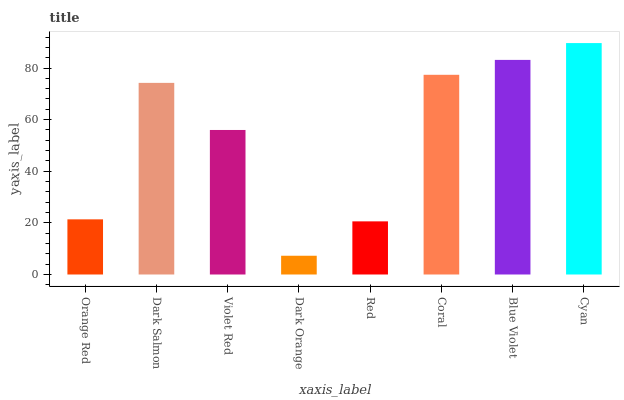Is Dark Orange the minimum?
Answer yes or no. Yes. Is Cyan the maximum?
Answer yes or no. Yes. Is Dark Salmon the minimum?
Answer yes or no. No. Is Dark Salmon the maximum?
Answer yes or no. No. Is Dark Salmon greater than Orange Red?
Answer yes or no. Yes. Is Orange Red less than Dark Salmon?
Answer yes or no. Yes. Is Orange Red greater than Dark Salmon?
Answer yes or no. No. Is Dark Salmon less than Orange Red?
Answer yes or no. No. Is Dark Salmon the high median?
Answer yes or no. Yes. Is Violet Red the low median?
Answer yes or no. Yes. Is Coral the high median?
Answer yes or no. No. Is Blue Violet the low median?
Answer yes or no. No. 